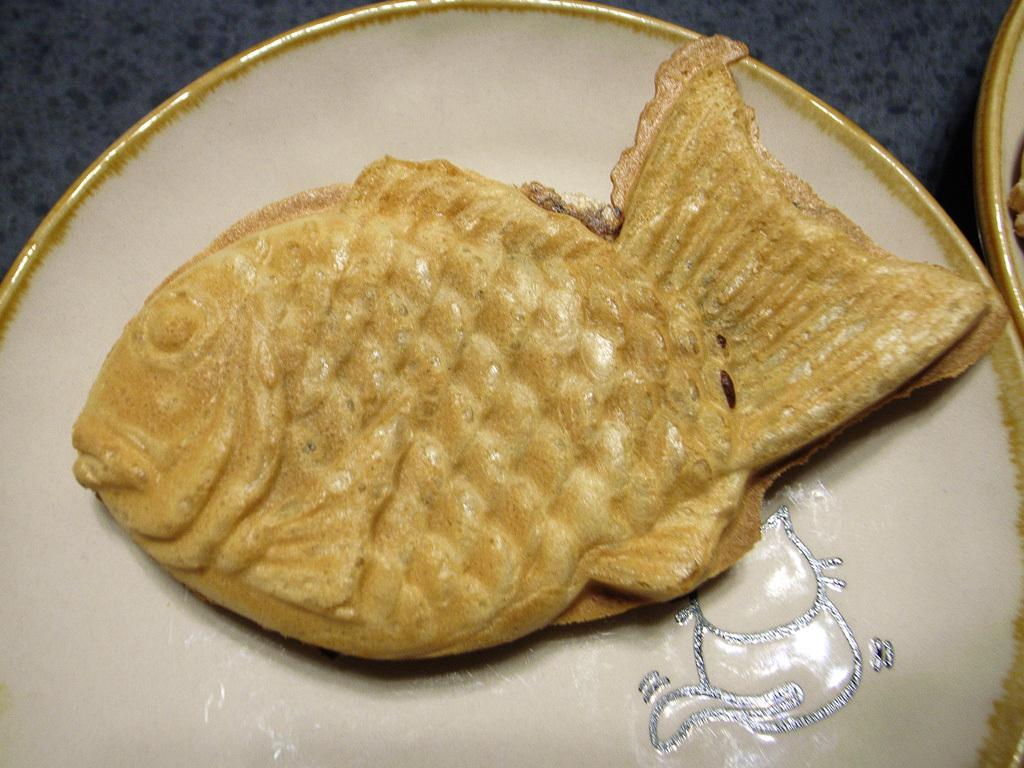What is on the white plate in the image? There is food on a white plate in the image. Can you see a lake in the background of the image? There is no mention of a lake or any background in the provided fact, so it cannot be determined from the image. 